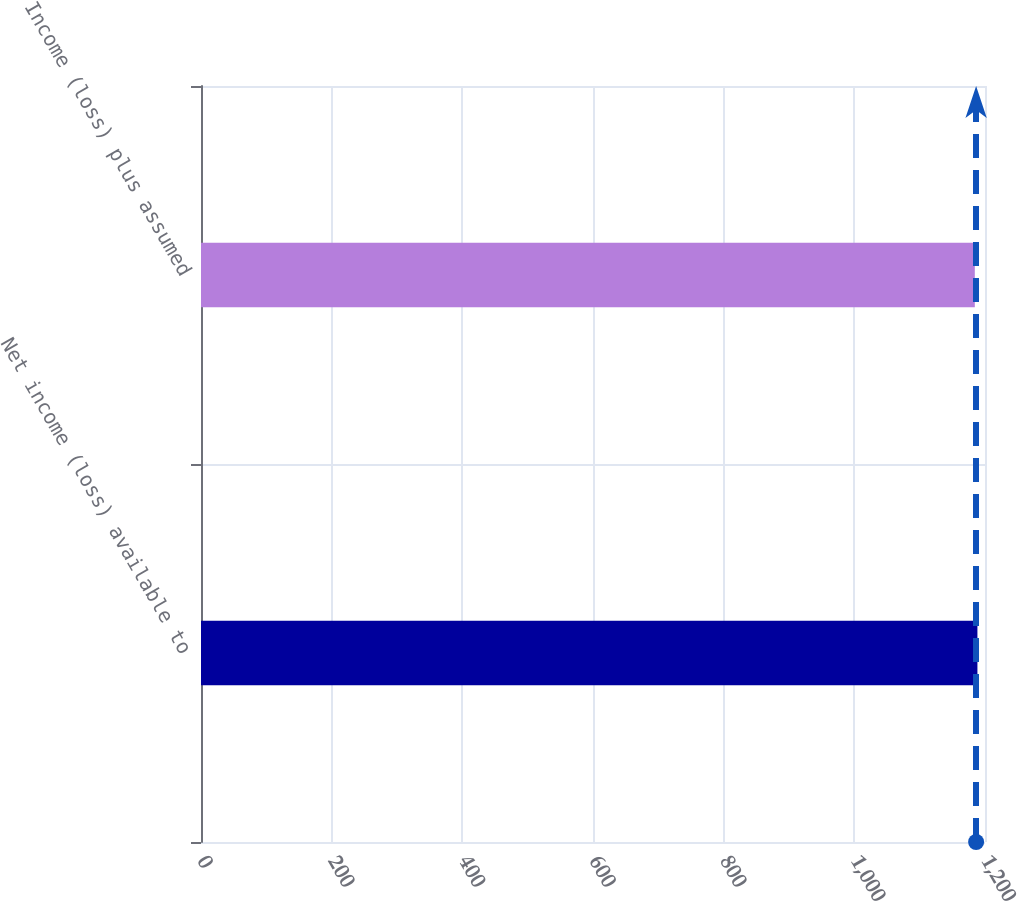<chart> <loc_0><loc_0><loc_500><loc_500><bar_chart><fcel>Net income (loss) available to<fcel>Income (loss) plus assumed<nl><fcel>1188.4<fcel>1184.4<nl></chart> 